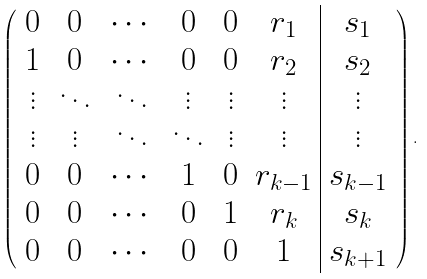Convert formula to latex. <formula><loc_0><loc_0><loc_500><loc_500>\left ( \begin{array} { c c c c c c | c } 0 & 0 & \cdots & 0 & 0 & r _ { 1 } & s _ { 1 } \\ 1 & 0 & \cdots & 0 & 0 & r _ { 2 } & s _ { 2 } \\ \vdots & \ddots & \ddots & \vdots & \vdots & \vdots & \vdots \\ \vdots & \vdots & \ddots & \ddots & \vdots & \vdots & \vdots \\ 0 & 0 & \cdots & 1 & 0 & r _ { k - 1 } & s _ { k - 1 } \\ 0 & 0 & \cdots & 0 & 1 & r _ { k } & s _ { k } \\ 0 & 0 & \cdots & 0 & 0 & 1 & s _ { k + 1 } \end{array} \right ) .</formula> 